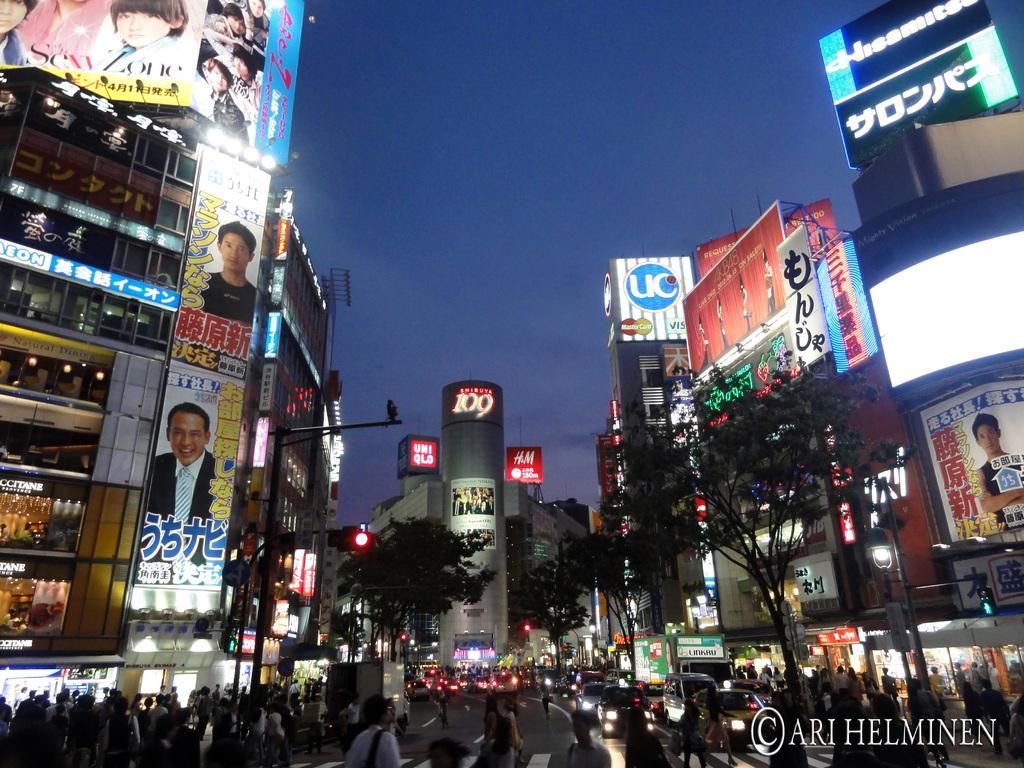Can you describe this image briefly? In this image we can see trees, light poles, buildings, hoarding, screen, people and vehicles. Background there is a sky. Right side bottom of the image there is a watermark. 